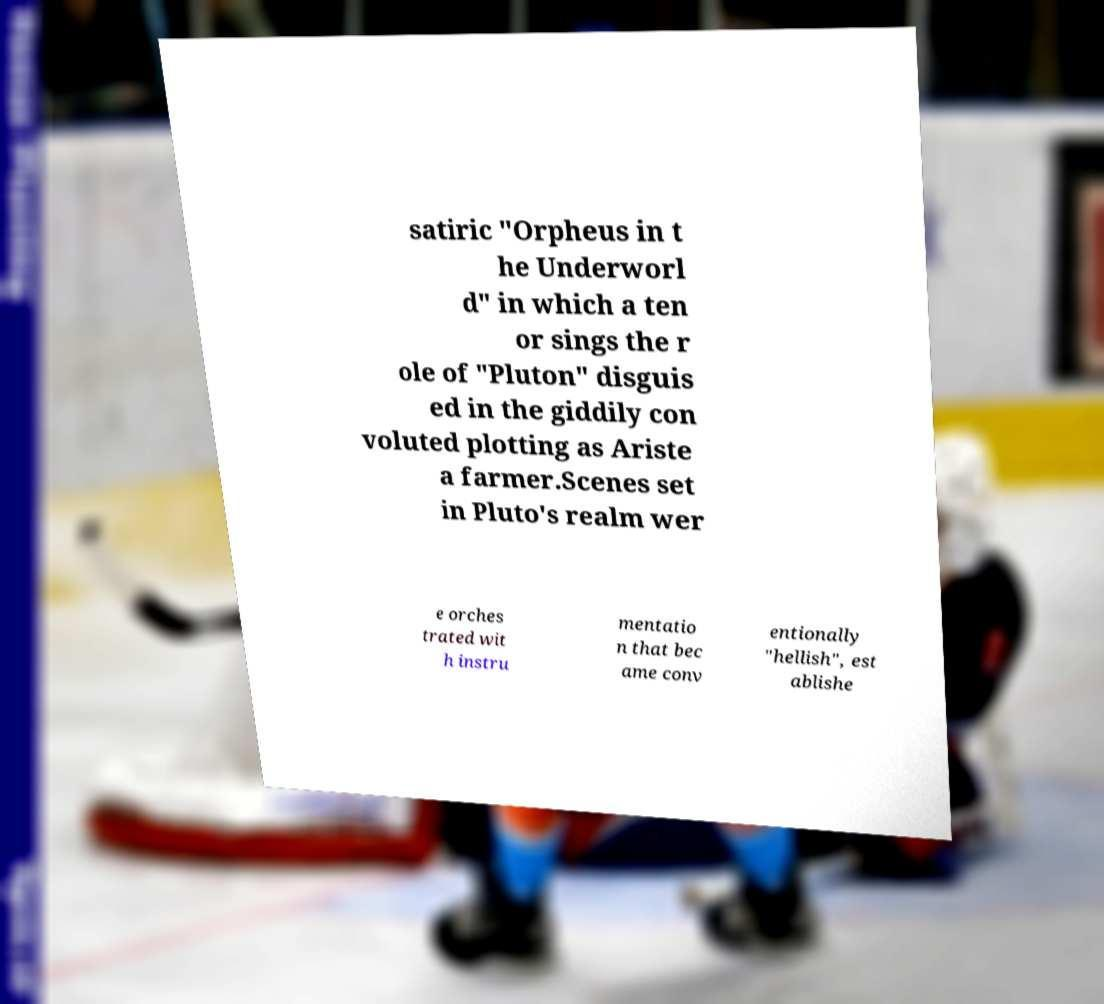Please read and relay the text visible in this image. What does it say? satiric "Orpheus in t he Underworl d" in which a ten or sings the r ole of "Pluton" disguis ed in the giddily con voluted plotting as Ariste a farmer.Scenes set in Pluto's realm wer e orches trated wit h instru mentatio n that bec ame conv entionally "hellish", est ablishe 